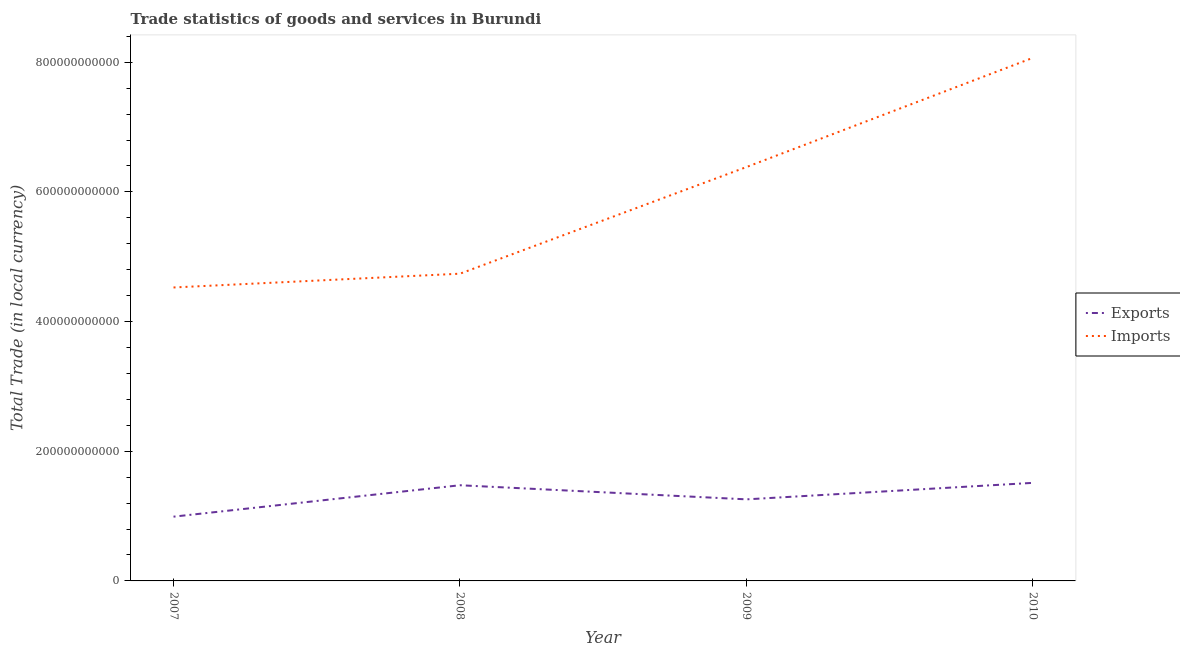How many different coloured lines are there?
Offer a terse response. 2. Does the line corresponding to export of goods and services intersect with the line corresponding to imports of goods and services?
Give a very brief answer. No. What is the imports of goods and services in 2009?
Provide a short and direct response. 6.38e+11. Across all years, what is the maximum export of goods and services?
Provide a short and direct response. 1.51e+11. Across all years, what is the minimum export of goods and services?
Your response must be concise. 9.91e+1. In which year was the imports of goods and services minimum?
Give a very brief answer. 2007. What is the total export of goods and services in the graph?
Provide a succinct answer. 5.24e+11. What is the difference between the export of goods and services in 2009 and that in 2010?
Keep it short and to the point. -2.54e+1. What is the difference between the imports of goods and services in 2008 and the export of goods and services in 2010?
Ensure brevity in your answer.  3.23e+11. What is the average export of goods and services per year?
Make the answer very short. 1.31e+11. In the year 2007, what is the difference between the imports of goods and services and export of goods and services?
Keep it short and to the point. 3.53e+11. What is the ratio of the imports of goods and services in 2008 to that in 2010?
Your response must be concise. 0.59. What is the difference between the highest and the second highest export of goods and services?
Provide a succinct answer. 3.68e+09. What is the difference between the highest and the lowest imports of goods and services?
Offer a terse response. 3.54e+11. Is the export of goods and services strictly less than the imports of goods and services over the years?
Provide a succinct answer. Yes. How many years are there in the graph?
Your response must be concise. 4. What is the difference between two consecutive major ticks on the Y-axis?
Your answer should be very brief. 2.00e+11. Are the values on the major ticks of Y-axis written in scientific E-notation?
Keep it short and to the point. No. Does the graph contain any zero values?
Provide a short and direct response. No. How many legend labels are there?
Your answer should be very brief. 2. What is the title of the graph?
Make the answer very short. Trade statistics of goods and services in Burundi. What is the label or title of the X-axis?
Provide a short and direct response. Year. What is the label or title of the Y-axis?
Provide a short and direct response. Total Trade (in local currency). What is the Total Trade (in local currency) in Exports in 2007?
Provide a short and direct response. 9.91e+1. What is the Total Trade (in local currency) of Imports in 2007?
Your answer should be compact. 4.53e+11. What is the Total Trade (in local currency) in Exports in 2008?
Your answer should be very brief. 1.48e+11. What is the Total Trade (in local currency) in Imports in 2008?
Your response must be concise. 4.74e+11. What is the Total Trade (in local currency) in Exports in 2009?
Offer a terse response. 1.26e+11. What is the Total Trade (in local currency) of Imports in 2009?
Offer a very short reply. 6.38e+11. What is the Total Trade (in local currency) in Exports in 2010?
Your answer should be very brief. 1.51e+11. What is the Total Trade (in local currency) of Imports in 2010?
Keep it short and to the point. 8.07e+11. Across all years, what is the maximum Total Trade (in local currency) in Exports?
Keep it short and to the point. 1.51e+11. Across all years, what is the maximum Total Trade (in local currency) of Imports?
Provide a short and direct response. 8.07e+11. Across all years, what is the minimum Total Trade (in local currency) of Exports?
Your answer should be compact. 9.91e+1. Across all years, what is the minimum Total Trade (in local currency) in Imports?
Your response must be concise. 4.53e+11. What is the total Total Trade (in local currency) in Exports in the graph?
Keep it short and to the point. 5.24e+11. What is the total Total Trade (in local currency) of Imports in the graph?
Keep it short and to the point. 2.37e+12. What is the difference between the Total Trade (in local currency) in Exports in 2007 and that in 2008?
Make the answer very short. -4.85e+1. What is the difference between the Total Trade (in local currency) in Imports in 2007 and that in 2008?
Your response must be concise. -2.13e+1. What is the difference between the Total Trade (in local currency) of Exports in 2007 and that in 2009?
Keep it short and to the point. -2.67e+1. What is the difference between the Total Trade (in local currency) in Imports in 2007 and that in 2009?
Provide a succinct answer. -1.86e+11. What is the difference between the Total Trade (in local currency) in Exports in 2007 and that in 2010?
Provide a succinct answer. -5.21e+1. What is the difference between the Total Trade (in local currency) of Imports in 2007 and that in 2010?
Ensure brevity in your answer.  -3.54e+11. What is the difference between the Total Trade (in local currency) in Exports in 2008 and that in 2009?
Ensure brevity in your answer.  2.18e+1. What is the difference between the Total Trade (in local currency) of Imports in 2008 and that in 2009?
Your answer should be very brief. -1.64e+11. What is the difference between the Total Trade (in local currency) of Exports in 2008 and that in 2010?
Provide a short and direct response. -3.68e+09. What is the difference between the Total Trade (in local currency) of Imports in 2008 and that in 2010?
Your answer should be very brief. -3.33e+11. What is the difference between the Total Trade (in local currency) in Exports in 2009 and that in 2010?
Keep it short and to the point. -2.54e+1. What is the difference between the Total Trade (in local currency) of Imports in 2009 and that in 2010?
Ensure brevity in your answer.  -1.68e+11. What is the difference between the Total Trade (in local currency) of Exports in 2007 and the Total Trade (in local currency) of Imports in 2008?
Keep it short and to the point. -3.75e+11. What is the difference between the Total Trade (in local currency) in Exports in 2007 and the Total Trade (in local currency) in Imports in 2009?
Provide a succinct answer. -5.39e+11. What is the difference between the Total Trade (in local currency) in Exports in 2007 and the Total Trade (in local currency) in Imports in 2010?
Ensure brevity in your answer.  -7.08e+11. What is the difference between the Total Trade (in local currency) in Exports in 2008 and the Total Trade (in local currency) in Imports in 2009?
Make the answer very short. -4.91e+11. What is the difference between the Total Trade (in local currency) in Exports in 2008 and the Total Trade (in local currency) in Imports in 2010?
Make the answer very short. -6.59e+11. What is the difference between the Total Trade (in local currency) of Exports in 2009 and the Total Trade (in local currency) of Imports in 2010?
Provide a short and direct response. -6.81e+11. What is the average Total Trade (in local currency) of Exports per year?
Offer a very short reply. 1.31e+11. What is the average Total Trade (in local currency) of Imports per year?
Your answer should be compact. 5.93e+11. In the year 2007, what is the difference between the Total Trade (in local currency) of Exports and Total Trade (in local currency) of Imports?
Your answer should be very brief. -3.53e+11. In the year 2008, what is the difference between the Total Trade (in local currency) in Exports and Total Trade (in local currency) in Imports?
Your response must be concise. -3.26e+11. In the year 2009, what is the difference between the Total Trade (in local currency) in Exports and Total Trade (in local currency) in Imports?
Make the answer very short. -5.13e+11. In the year 2010, what is the difference between the Total Trade (in local currency) in Exports and Total Trade (in local currency) in Imports?
Ensure brevity in your answer.  -6.56e+11. What is the ratio of the Total Trade (in local currency) of Exports in 2007 to that in 2008?
Provide a short and direct response. 0.67. What is the ratio of the Total Trade (in local currency) in Imports in 2007 to that in 2008?
Make the answer very short. 0.96. What is the ratio of the Total Trade (in local currency) in Exports in 2007 to that in 2009?
Your answer should be very brief. 0.79. What is the ratio of the Total Trade (in local currency) in Imports in 2007 to that in 2009?
Provide a succinct answer. 0.71. What is the ratio of the Total Trade (in local currency) of Exports in 2007 to that in 2010?
Your answer should be compact. 0.66. What is the ratio of the Total Trade (in local currency) in Imports in 2007 to that in 2010?
Keep it short and to the point. 0.56. What is the ratio of the Total Trade (in local currency) of Exports in 2008 to that in 2009?
Keep it short and to the point. 1.17. What is the ratio of the Total Trade (in local currency) of Imports in 2008 to that in 2009?
Provide a succinct answer. 0.74. What is the ratio of the Total Trade (in local currency) of Exports in 2008 to that in 2010?
Your response must be concise. 0.98. What is the ratio of the Total Trade (in local currency) of Imports in 2008 to that in 2010?
Give a very brief answer. 0.59. What is the ratio of the Total Trade (in local currency) of Exports in 2009 to that in 2010?
Give a very brief answer. 0.83. What is the ratio of the Total Trade (in local currency) in Imports in 2009 to that in 2010?
Your answer should be very brief. 0.79. What is the difference between the highest and the second highest Total Trade (in local currency) in Exports?
Keep it short and to the point. 3.68e+09. What is the difference between the highest and the second highest Total Trade (in local currency) of Imports?
Give a very brief answer. 1.68e+11. What is the difference between the highest and the lowest Total Trade (in local currency) of Exports?
Your answer should be compact. 5.21e+1. What is the difference between the highest and the lowest Total Trade (in local currency) in Imports?
Your response must be concise. 3.54e+11. 